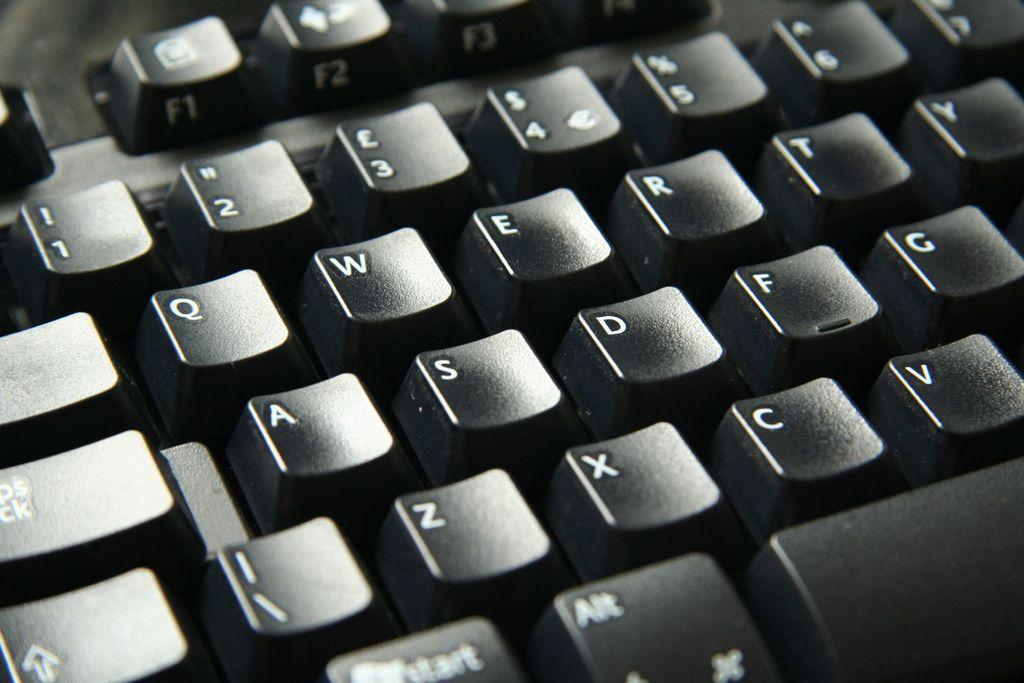What is the main object in the image? There is a keyboard in the image. What might the keyboard be used for? The keyboard is likely used for typing or playing music, depending on the context. What type of whistle is used to refuel the wax in the image? There is no whistle, fuel, or wax present in the image; it only features a keyboard. 